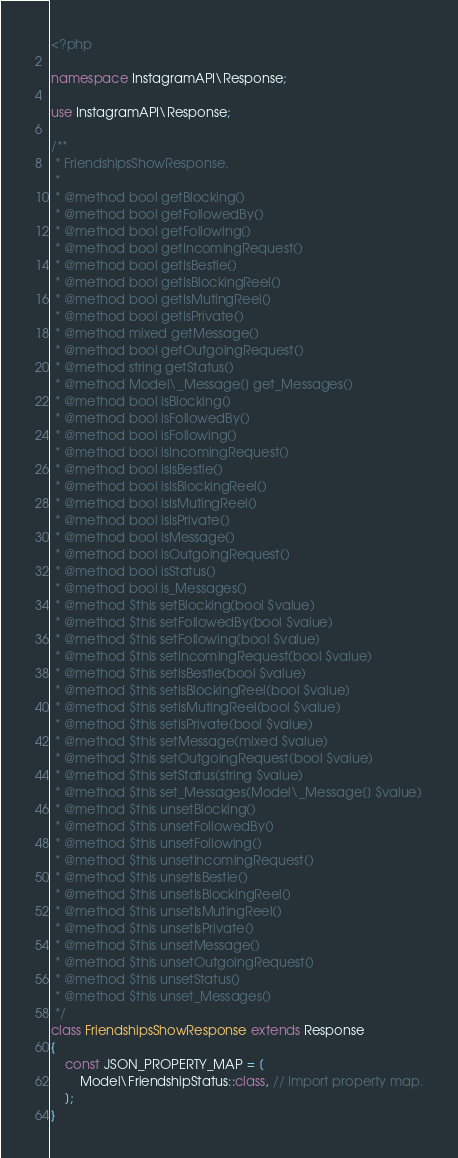Convert code to text. <code><loc_0><loc_0><loc_500><loc_500><_PHP_><?php

namespace InstagramAPI\Response;

use InstagramAPI\Response;

/**
 * FriendshipsShowResponse.
 *
 * @method bool getBlocking()
 * @method bool getFollowedBy()
 * @method bool getFollowing()
 * @method bool getIncomingRequest()
 * @method bool getIsBestie()
 * @method bool getIsBlockingReel()
 * @method bool getIsMutingReel()
 * @method bool getIsPrivate()
 * @method mixed getMessage()
 * @method bool getOutgoingRequest()
 * @method string getStatus()
 * @method Model\_Message[] get_Messages()
 * @method bool isBlocking()
 * @method bool isFollowedBy()
 * @method bool isFollowing()
 * @method bool isIncomingRequest()
 * @method bool isIsBestie()
 * @method bool isIsBlockingReel()
 * @method bool isIsMutingReel()
 * @method bool isIsPrivate()
 * @method bool isMessage()
 * @method bool isOutgoingRequest()
 * @method bool isStatus()
 * @method bool is_Messages()
 * @method $this setBlocking(bool $value)
 * @method $this setFollowedBy(bool $value)
 * @method $this setFollowing(bool $value)
 * @method $this setIncomingRequest(bool $value)
 * @method $this setIsBestie(bool $value)
 * @method $this setIsBlockingReel(bool $value)
 * @method $this setIsMutingReel(bool $value)
 * @method $this setIsPrivate(bool $value)
 * @method $this setMessage(mixed $value)
 * @method $this setOutgoingRequest(bool $value)
 * @method $this setStatus(string $value)
 * @method $this set_Messages(Model\_Message[] $value)
 * @method $this unsetBlocking()
 * @method $this unsetFollowedBy()
 * @method $this unsetFollowing()
 * @method $this unsetIncomingRequest()
 * @method $this unsetIsBestie()
 * @method $this unsetIsBlockingReel()
 * @method $this unsetIsMutingReel()
 * @method $this unsetIsPrivate()
 * @method $this unsetMessage()
 * @method $this unsetOutgoingRequest()
 * @method $this unsetStatus()
 * @method $this unset_Messages()
 */
class FriendshipsShowResponse extends Response
{
    const JSON_PROPERTY_MAP = [
        Model\FriendshipStatus::class, // Import property map.
    ];
}
</code> 